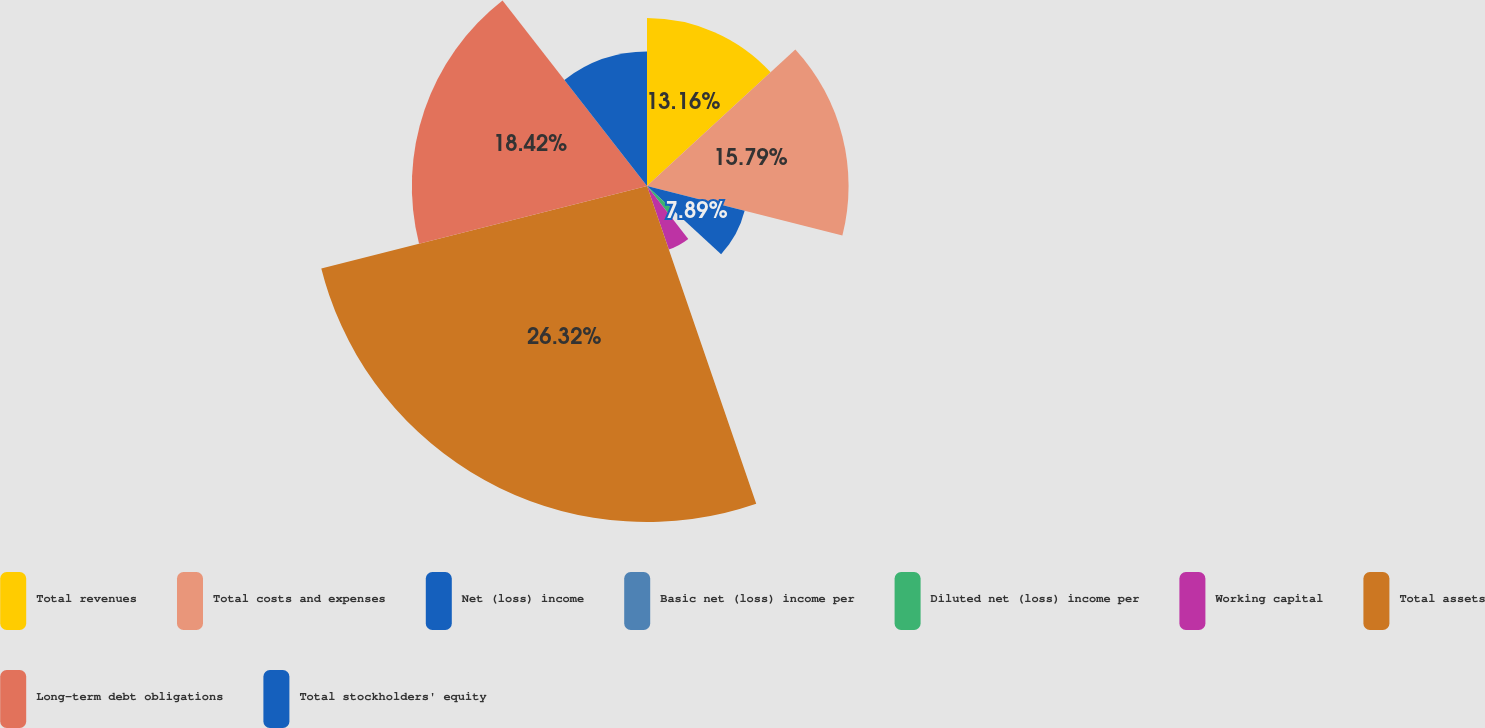Convert chart to OTSL. <chart><loc_0><loc_0><loc_500><loc_500><pie_chart><fcel>Total revenues<fcel>Total costs and expenses<fcel>Net (loss) income<fcel>Basic net (loss) income per<fcel>Diluted net (loss) income per<fcel>Working capital<fcel>Total assets<fcel>Long-term debt obligations<fcel>Total stockholders' equity<nl><fcel>13.16%<fcel>15.79%<fcel>7.89%<fcel>0.0%<fcel>2.63%<fcel>5.26%<fcel>26.32%<fcel>18.42%<fcel>10.53%<nl></chart> 